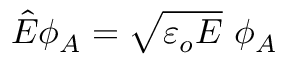Convert formula to latex. <formula><loc_0><loc_0><loc_500><loc_500>\hat { E } \phi _ { A } = \sqrt { \varepsilon _ { o } E } \ \phi _ { A }</formula> 